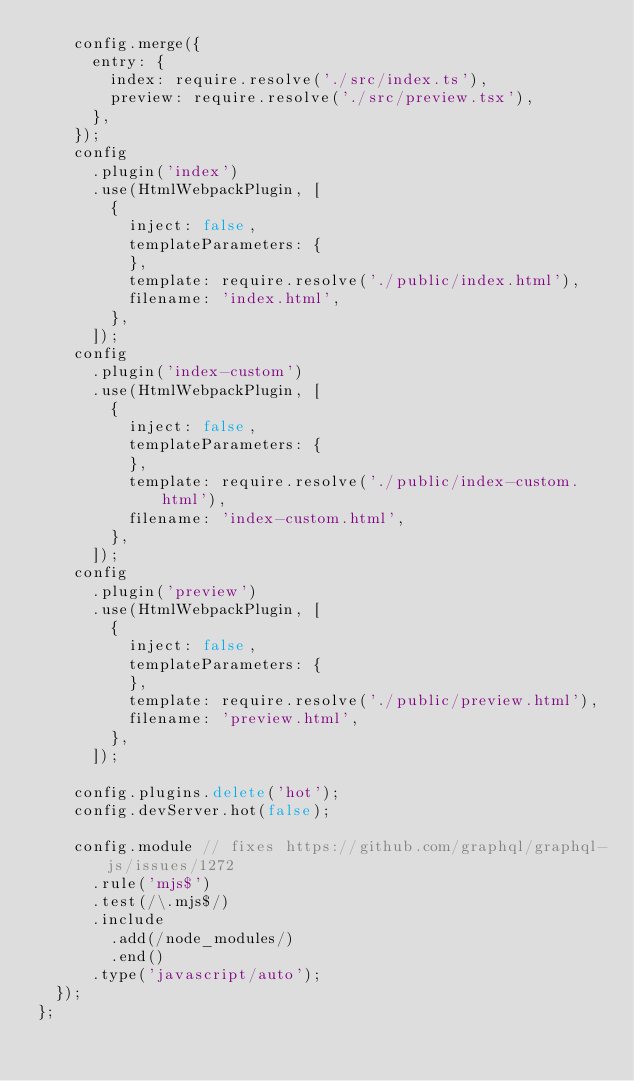Convert code to text. <code><loc_0><loc_0><loc_500><loc_500><_JavaScript_>    config.merge({
      entry: {
        index: require.resolve('./src/index.ts'),
        preview: require.resolve('./src/preview.tsx'),
      },
    });
    config
      .plugin('index')
      .use(HtmlWebpackPlugin, [
        {
          inject: false,
          templateParameters: {
          },
          template: require.resolve('./public/index.html'),
          filename: 'index.html',
        },
      ]);
    config
      .plugin('index-custom')
      .use(HtmlWebpackPlugin, [
        {
          inject: false,
          templateParameters: {
          },
          template: require.resolve('./public/index-custom.html'),
          filename: 'index-custom.html',
        },
      ]);
    config
      .plugin('preview')
      .use(HtmlWebpackPlugin, [
        {
          inject: false,
          templateParameters: {
          },
          template: require.resolve('./public/preview.html'),
          filename: 'preview.html',
        },
      ]);

    config.plugins.delete('hot');
    config.devServer.hot(false);

    config.module // fixes https://github.com/graphql/graphql-js/issues/1272
      .rule('mjs$')
      .test(/\.mjs$/)
      .include
        .add(/node_modules/)
        .end()
      .type('javascript/auto');
  });
};
</code> 